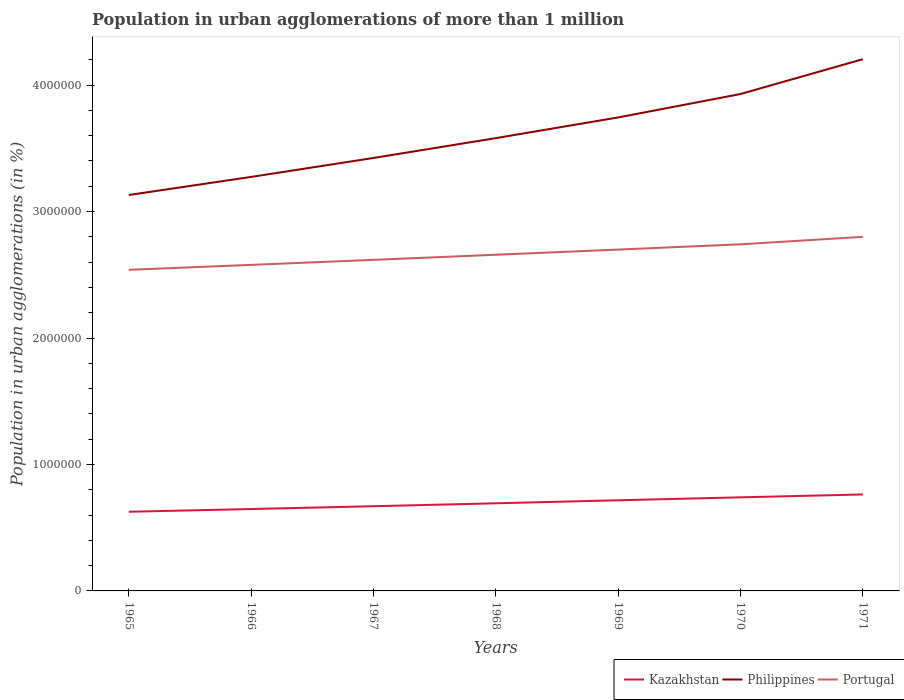How many different coloured lines are there?
Keep it short and to the point. 3. Does the line corresponding to Philippines intersect with the line corresponding to Kazakhstan?
Keep it short and to the point. No. Across all years, what is the maximum population in urban agglomerations in Portugal?
Offer a very short reply. 2.54e+06. In which year was the population in urban agglomerations in Portugal maximum?
Your response must be concise. 1965. What is the total population in urban agglomerations in Portugal in the graph?
Give a very brief answer. -1.42e+05. What is the difference between the highest and the second highest population in urban agglomerations in Portugal?
Your answer should be very brief. 2.61e+05. How many lines are there?
Offer a terse response. 3. How many years are there in the graph?
Give a very brief answer. 7. Are the values on the major ticks of Y-axis written in scientific E-notation?
Keep it short and to the point. No. How many legend labels are there?
Offer a terse response. 3. How are the legend labels stacked?
Your response must be concise. Horizontal. What is the title of the graph?
Ensure brevity in your answer.  Population in urban agglomerations of more than 1 million. Does "Mauritius" appear as one of the legend labels in the graph?
Your response must be concise. No. What is the label or title of the X-axis?
Keep it short and to the point. Years. What is the label or title of the Y-axis?
Ensure brevity in your answer.  Population in urban agglomerations (in %). What is the Population in urban agglomerations (in %) of Kazakhstan in 1965?
Ensure brevity in your answer.  6.26e+05. What is the Population in urban agglomerations (in %) in Philippines in 1965?
Offer a terse response. 3.13e+06. What is the Population in urban agglomerations (in %) of Portugal in 1965?
Your answer should be very brief. 2.54e+06. What is the Population in urban agglomerations (in %) of Kazakhstan in 1966?
Offer a very short reply. 6.48e+05. What is the Population in urban agglomerations (in %) of Philippines in 1966?
Provide a succinct answer. 3.27e+06. What is the Population in urban agglomerations (in %) in Portugal in 1966?
Offer a very short reply. 2.58e+06. What is the Population in urban agglomerations (in %) in Kazakhstan in 1967?
Your answer should be very brief. 6.70e+05. What is the Population in urban agglomerations (in %) in Philippines in 1967?
Ensure brevity in your answer.  3.42e+06. What is the Population in urban agglomerations (in %) of Portugal in 1967?
Keep it short and to the point. 2.62e+06. What is the Population in urban agglomerations (in %) in Kazakhstan in 1968?
Provide a short and direct response. 6.93e+05. What is the Population in urban agglomerations (in %) of Philippines in 1968?
Your answer should be very brief. 3.58e+06. What is the Population in urban agglomerations (in %) of Portugal in 1968?
Give a very brief answer. 2.66e+06. What is the Population in urban agglomerations (in %) in Kazakhstan in 1969?
Make the answer very short. 7.17e+05. What is the Population in urban agglomerations (in %) in Philippines in 1969?
Keep it short and to the point. 3.74e+06. What is the Population in urban agglomerations (in %) of Portugal in 1969?
Make the answer very short. 2.70e+06. What is the Population in urban agglomerations (in %) in Kazakhstan in 1970?
Ensure brevity in your answer.  7.40e+05. What is the Population in urban agglomerations (in %) of Philippines in 1970?
Ensure brevity in your answer.  3.93e+06. What is the Population in urban agglomerations (in %) of Portugal in 1970?
Keep it short and to the point. 2.74e+06. What is the Population in urban agglomerations (in %) of Kazakhstan in 1971?
Your answer should be very brief. 7.63e+05. What is the Population in urban agglomerations (in %) of Philippines in 1971?
Make the answer very short. 4.20e+06. What is the Population in urban agglomerations (in %) of Portugal in 1971?
Keep it short and to the point. 2.80e+06. Across all years, what is the maximum Population in urban agglomerations (in %) of Kazakhstan?
Your answer should be very brief. 7.63e+05. Across all years, what is the maximum Population in urban agglomerations (in %) in Philippines?
Provide a succinct answer. 4.20e+06. Across all years, what is the maximum Population in urban agglomerations (in %) of Portugal?
Keep it short and to the point. 2.80e+06. Across all years, what is the minimum Population in urban agglomerations (in %) of Kazakhstan?
Offer a terse response. 6.26e+05. Across all years, what is the minimum Population in urban agglomerations (in %) in Philippines?
Give a very brief answer. 3.13e+06. Across all years, what is the minimum Population in urban agglomerations (in %) in Portugal?
Your answer should be compact. 2.54e+06. What is the total Population in urban agglomerations (in %) in Kazakhstan in the graph?
Make the answer very short. 4.86e+06. What is the total Population in urban agglomerations (in %) of Philippines in the graph?
Offer a terse response. 2.53e+07. What is the total Population in urban agglomerations (in %) of Portugal in the graph?
Offer a terse response. 1.86e+07. What is the difference between the Population in urban agglomerations (in %) of Kazakhstan in 1965 and that in 1966?
Your answer should be compact. -2.15e+04. What is the difference between the Population in urban agglomerations (in %) of Philippines in 1965 and that in 1966?
Your response must be concise. -1.43e+05. What is the difference between the Population in urban agglomerations (in %) of Portugal in 1965 and that in 1966?
Your response must be concise. -3.90e+04. What is the difference between the Population in urban agglomerations (in %) in Kazakhstan in 1965 and that in 1967?
Give a very brief answer. -4.38e+04. What is the difference between the Population in urban agglomerations (in %) of Philippines in 1965 and that in 1967?
Offer a terse response. -2.93e+05. What is the difference between the Population in urban agglomerations (in %) of Portugal in 1965 and that in 1967?
Give a very brief answer. -7.87e+04. What is the difference between the Population in urban agglomerations (in %) of Kazakhstan in 1965 and that in 1968?
Your answer should be very brief. -6.69e+04. What is the difference between the Population in urban agglomerations (in %) of Philippines in 1965 and that in 1968?
Provide a succinct answer. -4.50e+05. What is the difference between the Population in urban agglomerations (in %) in Portugal in 1965 and that in 1968?
Provide a short and direct response. -1.19e+05. What is the difference between the Population in urban agglomerations (in %) of Kazakhstan in 1965 and that in 1969?
Your answer should be compact. -9.07e+04. What is the difference between the Population in urban agglomerations (in %) in Philippines in 1965 and that in 1969?
Give a very brief answer. -6.13e+05. What is the difference between the Population in urban agglomerations (in %) of Portugal in 1965 and that in 1969?
Your answer should be very brief. -1.60e+05. What is the difference between the Population in urban agglomerations (in %) of Kazakhstan in 1965 and that in 1970?
Your answer should be compact. -1.14e+05. What is the difference between the Population in urban agglomerations (in %) of Philippines in 1965 and that in 1970?
Your answer should be compact. -7.99e+05. What is the difference between the Population in urban agglomerations (in %) in Portugal in 1965 and that in 1970?
Ensure brevity in your answer.  -2.02e+05. What is the difference between the Population in urban agglomerations (in %) of Kazakhstan in 1965 and that in 1971?
Give a very brief answer. -1.37e+05. What is the difference between the Population in urban agglomerations (in %) in Philippines in 1965 and that in 1971?
Offer a terse response. -1.07e+06. What is the difference between the Population in urban agglomerations (in %) of Portugal in 1965 and that in 1971?
Provide a short and direct response. -2.61e+05. What is the difference between the Population in urban agglomerations (in %) of Kazakhstan in 1966 and that in 1967?
Provide a succinct answer. -2.23e+04. What is the difference between the Population in urban agglomerations (in %) in Philippines in 1966 and that in 1967?
Ensure brevity in your answer.  -1.50e+05. What is the difference between the Population in urban agglomerations (in %) of Portugal in 1966 and that in 1967?
Offer a terse response. -3.97e+04. What is the difference between the Population in urban agglomerations (in %) of Kazakhstan in 1966 and that in 1968?
Your answer should be compact. -4.54e+04. What is the difference between the Population in urban agglomerations (in %) of Philippines in 1966 and that in 1968?
Offer a very short reply. -3.07e+05. What is the difference between the Population in urban agglomerations (in %) in Portugal in 1966 and that in 1968?
Ensure brevity in your answer.  -8.00e+04. What is the difference between the Population in urban agglomerations (in %) of Kazakhstan in 1966 and that in 1969?
Make the answer very short. -6.92e+04. What is the difference between the Population in urban agglomerations (in %) of Philippines in 1966 and that in 1969?
Keep it short and to the point. -4.70e+05. What is the difference between the Population in urban agglomerations (in %) in Portugal in 1966 and that in 1969?
Your response must be concise. -1.21e+05. What is the difference between the Population in urban agglomerations (in %) of Kazakhstan in 1966 and that in 1970?
Your answer should be very brief. -9.25e+04. What is the difference between the Population in urban agglomerations (in %) in Philippines in 1966 and that in 1970?
Provide a succinct answer. -6.55e+05. What is the difference between the Population in urban agglomerations (in %) of Portugal in 1966 and that in 1970?
Your answer should be very brief. -1.63e+05. What is the difference between the Population in urban agglomerations (in %) of Kazakhstan in 1966 and that in 1971?
Make the answer very short. -1.15e+05. What is the difference between the Population in urban agglomerations (in %) in Philippines in 1966 and that in 1971?
Ensure brevity in your answer.  -9.31e+05. What is the difference between the Population in urban agglomerations (in %) of Portugal in 1966 and that in 1971?
Make the answer very short. -2.22e+05. What is the difference between the Population in urban agglomerations (in %) of Kazakhstan in 1967 and that in 1968?
Ensure brevity in your answer.  -2.31e+04. What is the difference between the Population in urban agglomerations (in %) of Philippines in 1967 and that in 1968?
Your answer should be compact. -1.57e+05. What is the difference between the Population in urban agglomerations (in %) of Portugal in 1967 and that in 1968?
Your response must be concise. -4.04e+04. What is the difference between the Population in urban agglomerations (in %) of Kazakhstan in 1967 and that in 1969?
Give a very brief answer. -4.69e+04. What is the difference between the Population in urban agglomerations (in %) of Philippines in 1967 and that in 1969?
Your response must be concise. -3.20e+05. What is the difference between the Population in urban agglomerations (in %) in Portugal in 1967 and that in 1969?
Your answer should be compact. -8.13e+04. What is the difference between the Population in urban agglomerations (in %) of Kazakhstan in 1967 and that in 1970?
Your response must be concise. -7.03e+04. What is the difference between the Population in urban agglomerations (in %) of Philippines in 1967 and that in 1970?
Offer a very short reply. -5.06e+05. What is the difference between the Population in urban agglomerations (in %) in Portugal in 1967 and that in 1970?
Give a very brief answer. -1.23e+05. What is the difference between the Population in urban agglomerations (in %) in Kazakhstan in 1967 and that in 1971?
Offer a terse response. -9.28e+04. What is the difference between the Population in urban agglomerations (in %) in Philippines in 1967 and that in 1971?
Provide a short and direct response. -7.81e+05. What is the difference between the Population in urban agglomerations (in %) in Portugal in 1967 and that in 1971?
Make the answer very short. -1.82e+05. What is the difference between the Population in urban agglomerations (in %) of Kazakhstan in 1968 and that in 1969?
Provide a succinct answer. -2.38e+04. What is the difference between the Population in urban agglomerations (in %) of Philippines in 1968 and that in 1969?
Your answer should be very brief. -1.64e+05. What is the difference between the Population in urban agglomerations (in %) of Portugal in 1968 and that in 1969?
Your response must be concise. -4.09e+04. What is the difference between the Population in urban agglomerations (in %) of Kazakhstan in 1968 and that in 1970?
Give a very brief answer. -4.72e+04. What is the difference between the Population in urban agglomerations (in %) in Philippines in 1968 and that in 1970?
Your answer should be very brief. -3.49e+05. What is the difference between the Population in urban agglomerations (in %) of Portugal in 1968 and that in 1970?
Give a very brief answer. -8.26e+04. What is the difference between the Population in urban agglomerations (in %) of Kazakhstan in 1968 and that in 1971?
Offer a terse response. -6.98e+04. What is the difference between the Population in urban agglomerations (in %) of Philippines in 1968 and that in 1971?
Offer a very short reply. -6.24e+05. What is the difference between the Population in urban agglomerations (in %) in Portugal in 1968 and that in 1971?
Provide a succinct answer. -1.42e+05. What is the difference between the Population in urban agglomerations (in %) in Kazakhstan in 1969 and that in 1970?
Provide a succinct answer. -2.34e+04. What is the difference between the Population in urban agglomerations (in %) in Philippines in 1969 and that in 1970?
Your response must be concise. -1.85e+05. What is the difference between the Population in urban agglomerations (in %) of Portugal in 1969 and that in 1970?
Ensure brevity in your answer.  -4.17e+04. What is the difference between the Population in urban agglomerations (in %) of Kazakhstan in 1969 and that in 1971?
Offer a very short reply. -4.59e+04. What is the difference between the Population in urban agglomerations (in %) of Philippines in 1969 and that in 1971?
Your answer should be compact. -4.61e+05. What is the difference between the Population in urban agglomerations (in %) of Portugal in 1969 and that in 1971?
Your answer should be very brief. -1.01e+05. What is the difference between the Population in urban agglomerations (in %) of Kazakhstan in 1970 and that in 1971?
Give a very brief answer. -2.26e+04. What is the difference between the Population in urban agglomerations (in %) in Philippines in 1970 and that in 1971?
Ensure brevity in your answer.  -2.75e+05. What is the difference between the Population in urban agglomerations (in %) of Portugal in 1970 and that in 1971?
Your response must be concise. -5.90e+04. What is the difference between the Population in urban agglomerations (in %) of Kazakhstan in 1965 and the Population in urban agglomerations (in %) of Philippines in 1966?
Your response must be concise. -2.65e+06. What is the difference between the Population in urban agglomerations (in %) in Kazakhstan in 1965 and the Population in urban agglomerations (in %) in Portugal in 1966?
Ensure brevity in your answer.  -1.95e+06. What is the difference between the Population in urban agglomerations (in %) of Philippines in 1965 and the Population in urban agglomerations (in %) of Portugal in 1966?
Provide a short and direct response. 5.52e+05. What is the difference between the Population in urban agglomerations (in %) in Kazakhstan in 1965 and the Population in urban agglomerations (in %) in Philippines in 1967?
Give a very brief answer. -2.80e+06. What is the difference between the Population in urban agglomerations (in %) of Kazakhstan in 1965 and the Population in urban agglomerations (in %) of Portugal in 1967?
Give a very brief answer. -1.99e+06. What is the difference between the Population in urban agglomerations (in %) in Philippines in 1965 and the Population in urban agglomerations (in %) in Portugal in 1967?
Your answer should be compact. 5.13e+05. What is the difference between the Population in urban agglomerations (in %) in Kazakhstan in 1965 and the Population in urban agglomerations (in %) in Philippines in 1968?
Your answer should be very brief. -2.95e+06. What is the difference between the Population in urban agglomerations (in %) in Kazakhstan in 1965 and the Population in urban agglomerations (in %) in Portugal in 1968?
Your response must be concise. -2.03e+06. What is the difference between the Population in urban agglomerations (in %) of Philippines in 1965 and the Population in urban agglomerations (in %) of Portugal in 1968?
Your answer should be very brief. 4.72e+05. What is the difference between the Population in urban agglomerations (in %) of Kazakhstan in 1965 and the Population in urban agglomerations (in %) of Philippines in 1969?
Give a very brief answer. -3.12e+06. What is the difference between the Population in urban agglomerations (in %) in Kazakhstan in 1965 and the Population in urban agglomerations (in %) in Portugal in 1969?
Offer a very short reply. -2.07e+06. What is the difference between the Population in urban agglomerations (in %) in Philippines in 1965 and the Population in urban agglomerations (in %) in Portugal in 1969?
Give a very brief answer. 4.32e+05. What is the difference between the Population in urban agglomerations (in %) in Kazakhstan in 1965 and the Population in urban agglomerations (in %) in Philippines in 1970?
Ensure brevity in your answer.  -3.30e+06. What is the difference between the Population in urban agglomerations (in %) of Kazakhstan in 1965 and the Population in urban agglomerations (in %) of Portugal in 1970?
Provide a succinct answer. -2.11e+06. What is the difference between the Population in urban agglomerations (in %) in Philippines in 1965 and the Population in urban agglomerations (in %) in Portugal in 1970?
Offer a terse response. 3.90e+05. What is the difference between the Population in urban agglomerations (in %) in Kazakhstan in 1965 and the Population in urban agglomerations (in %) in Philippines in 1971?
Keep it short and to the point. -3.58e+06. What is the difference between the Population in urban agglomerations (in %) in Kazakhstan in 1965 and the Population in urban agglomerations (in %) in Portugal in 1971?
Your answer should be very brief. -2.17e+06. What is the difference between the Population in urban agglomerations (in %) in Philippines in 1965 and the Population in urban agglomerations (in %) in Portugal in 1971?
Ensure brevity in your answer.  3.31e+05. What is the difference between the Population in urban agglomerations (in %) of Kazakhstan in 1966 and the Population in urban agglomerations (in %) of Philippines in 1967?
Your response must be concise. -2.78e+06. What is the difference between the Population in urban agglomerations (in %) of Kazakhstan in 1966 and the Population in urban agglomerations (in %) of Portugal in 1967?
Make the answer very short. -1.97e+06. What is the difference between the Population in urban agglomerations (in %) in Philippines in 1966 and the Population in urban agglomerations (in %) in Portugal in 1967?
Your answer should be compact. 6.56e+05. What is the difference between the Population in urban agglomerations (in %) of Kazakhstan in 1966 and the Population in urban agglomerations (in %) of Philippines in 1968?
Make the answer very short. -2.93e+06. What is the difference between the Population in urban agglomerations (in %) in Kazakhstan in 1966 and the Population in urban agglomerations (in %) in Portugal in 1968?
Provide a short and direct response. -2.01e+06. What is the difference between the Population in urban agglomerations (in %) of Philippines in 1966 and the Population in urban agglomerations (in %) of Portugal in 1968?
Make the answer very short. 6.16e+05. What is the difference between the Population in urban agglomerations (in %) of Kazakhstan in 1966 and the Population in urban agglomerations (in %) of Philippines in 1969?
Your response must be concise. -3.10e+06. What is the difference between the Population in urban agglomerations (in %) of Kazakhstan in 1966 and the Population in urban agglomerations (in %) of Portugal in 1969?
Offer a terse response. -2.05e+06. What is the difference between the Population in urban agglomerations (in %) in Philippines in 1966 and the Population in urban agglomerations (in %) in Portugal in 1969?
Offer a terse response. 5.75e+05. What is the difference between the Population in urban agglomerations (in %) in Kazakhstan in 1966 and the Population in urban agglomerations (in %) in Philippines in 1970?
Ensure brevity in your answer.  -3.28e+06. What is the difference between the Population in urban agglomerations (in %) in Kazakhstan in 1966 and the Population in urban agglomerations (in %) in Portugal in 1970?
Your response must be concise. -2.09e+06. What is the difference between the Population in urban agglomerations (in %) in Philippines in 1966 and the Population in urban agglomerations (in %) in Portugal in 1970?
Provide a short and direct response. 5.33e+05. What is the difference between the Population in urban agglomerations (in %) of Kazakhstan in 1966 and the Population in urban agglomerations (in %) of Philippines in 1971?
Provide a short and direct response. -3.56e+06. What is the difference between the Population in urban agglomerations (in %) of Kazakhstan in 1966 and the Population in urban agglomerations (in %) of Portugal in 1971?
Your response must be concise. -2.15e+06. What is the difference between the Population in urban agglomerations (in %) in Philippines in 1966 and the Population in urban agglomerations (in %) in Portugal in 1971?
Your answer should be very brief. 4.74e+05. What is the difference between the Population in urban agglomerations (in %) of Kazakhstan in 1967 and the Population in urban agglomerations (in %) of Philippines in 1968?
Your response must be concise. -2.91e+06. What is the difference between the Population in urban agglomerations (in %) of Kazakhstan in 1967 and the Population in urban agglomerations (in %) of Portugal in 1968?
Keep it short and to the point. -1.99e+06. What is the difference between the Population in urban agglomerations (in %) of Philippines in 1967 and the Population in urban agglomerations (in %) of Portugal in 1968?
Ensure brevity in your answer.  7.65e+05. What is the difference between the Population in urban agglomerations (in %) in Kazakhstan in 1967 and the Population in urban agglomerations (in %) in Philippines in 1969?
Give a very brief answer. -3.07e+06. What is the difference between the Population in urban agglomerations (in %) in Kazakhstan in 1967 and the Population in urban agglomerations (in %) in Portugal in 1969?
Your response must be concise. -2.03e+06. What is the difference between the Population in urban agglomerations (in %) of Philippines in 1967 and the Population in urban agglomerations (in %) of Portugal in 1969?
Your answer should be compact. 7.24e+05. What is the difference between the Population in urban agglomerations (in %) of Kazakhstan in 1967 and the Population in urban agglomerations (in %) of Philippines in 1970?
Your answer should be compact. -3.26e+06. What is the difference between the Population in urban agglomerations (in %) of Kazakhstan in 1967 and the Population in urban agglomerations (in %) of Portugal in 1970?
Your response must be concise. -2.07e+06. What is the difference between the Population in urban agglomerations (in %) in Philippines in 1967 and the Population in urban agglomerations (in %) in Portugal in 1970?
Your response must be concise. 6.83e+05. What is the difference between the Population in urban agglomerations (in %) of Kazakhstan in 1967 and the Population in urban agglomerations (in %) of Philippines in 1971?
Give a very brief answer. -3.53e+06. What is the difference between the Population in urban agglomerations (in %) in Kazakhstan in 1967 and the Population in urban agglomerations (in %) in Portugal in 1971?
Provide a short and direct response. -2.13e+06. What is the difference between the Population in urban agglomerations (in %) of Philippines in 1967 and the Population in urban agglomerations (in %) of Portugal in 1971?
Make the answer very short. 6.24e+05. What is the difference between the Population in urban agglomerations (in %) of Kazakhstan in 1968 and the Population in urban agglomerations (in %) of Philippines in 1969?
Make the answer very short. -3.05e+06. What is the difference between the Population in urban agglomerations (in %) of Kazakhstan in 1968 and the Population in urban agglomerations (in %) of Portugal in 1969?
Your answer should be very brief. -2.01e+06. What is the difference between the Population in urban agglomerations (in %) of Philippines in 1968 and the Population in urban agglomerations (in %) of Portugal in 1969?
Give a very brief answer. 8.81e+05. What is the difference between the Population in urban agglomerations (in %) in Kazakhstan in 1968 and the Population in urban agglomerations (in %) in Philippines in 1970?
Your answer should be compact. -3.24e+06. What is the difference between the Population in urban agglomerations (in %) in Kazakhstan in 1968 and the Population in urban agglomerations (in %) in Portugal in 1970?
Ensure brevity in your answer.  -2.05e+06. What is the difference between the Population in urban agglomerations (in %) of Philippines in 1968 and the Population in urban agglomerations (in %) of Portugal in 1970?
Ensure brevity in your answer.  8.40e+05. What is the difference between the Population in urban agglomerations (in %) of Kazakhstan in 1968 and the Population in urban agglomerations (in %) of Philippines in 1971?
Ensure brevity in your answer.  -3.51e+06. What is the difference between the Population in urban agglomerations (in %) of Kazakhstan in 1968 and the Population in urban agglomerations (in %) of Portugal in 1971?
Keep it short and to the point. -2.11e+06. What is the difference between the Population in urban agglomerations (in %) of Philippines in 1968 and the Population in urban agglomerations (in %) of Portugal in 1971?
Provide a short and direct response. 7.81e+05. What is the difference between the Population in urban agglomerations (in %) of Kazakhstan in 1969 and the Population in urban agglomerations (in %) of Philippines in 1970?
Make the answer very short. -3.21e+06. What is the difference between the Population in urban agglomerations (in %) in Kazakhstan in 1969 and the Population in urban agglomerations (in %) in Portugal in 1970?
Your response must be concise. -2.02e+06. What is the difference between the Population in urban agglomerations (in %) of Philippines in 1969 and the Population in urban agglomerations (in %) of Portugal in 1970?
Make the answer very short. 1.00e+06. What is the difference between the Population in urban agglomerations (in %) of Kazakhstan in 1969 and the Population in urban agglomerations (in %) of Philippines in 1971?
Make the answer very short. -3.49e+06. What is the difference between the Population in urban agglomerations (in %) of Kazakhstan in 1969 and the Population in urban agglomerations (in %) of Portugal in 1971?
Ensure brevity in your answer.  -2.08e+06. What is the difference between the Population in urban agglomerations (in %) in Philippines in 1969 and the Population in urban agglomerations (in %) in Portugal in 1971?
Give a very brief answer. 9.44e+05. What is the difference between the Population in urban agglomerations (in %) in Kazakhstan in 1970 and the Population in urban agglomerations (in %) in Philippines in 1971?
Provide a short and direct response. -3.46e+06. What is the difference between the Population in urban agglomerations (in %) of Kazakhstan in 1970 and the Population in urban agglomerations (in %) of Portugal in 1971?
Your response must be concise. -2.06e+06. What is the difference between the Population in urban agglomerations (in %) of Philippines in 1970 and the Population in urban agglomerations (in %) of Portugal in 1971?
Ensure brevity in your answer.  1.13e+06. What is the average Population in urban agglomerations (in %) of Kazakhstan per year?
Offer a terse response. 6.94e+05. What is the average Population in urban agglomerations (in %) of Philippines per year?
Give a very brief answer. 3.61e+06. What is the average Population in urban agglomerations (in %) of Portugal per year?
Offer a terse response. 2.66e+06. In the year 1965, what is the difference between the Population in urban agglomerations (in %) in Kazakhstan and Population in urban agglomerations (in %) in Philippines?
Provide a succinct answer. -2.50e+06. In the year 1965, what is the difference between the Population in urban agglomerations (in %) of Kazakhstan and Population in urban agglomerations (in %) of Portugal?
Give a very brief answer. -1.91e+06. In the year 1965, what is the difference between the Population in urban agglomerations (in %) of Philippines and Population in urban agglomerations (in %) of Portugal?
Your answer should be very brief. 5.92e+05. In the year 1966, what is the difference between the Population in urban agglomerations (in %) of Kazakhstan and Population in urban agglomerations (in %) of Philippines?
Your answer should be compact. -2.63e+06. In the year 1966, what is the difference between the Population in urban agglomerations (in %) of Kazakhstan and Population in urban agglomerations (in %) of Portugal?
Keep it short and to the point. -1.93e+06. In the year 1966, what is the difference between the Population in urban agglomerations (in %) in Philippines and Population in urban agglomerations (in %) in Portugal?
Your response must be concise. 6.96e+05. In the year 1967, what is the difference between the Population in urban agglomerations (in %) in Kazakhstan and Population in urban agglomerations (in %) in Philippines?
Ensure brevity in your answer.  -2.75e+06. In the year 1967, what is the difference between the Population in urban agglomerations (in %) in Kazakhstan and Population in urban agglomerations (in %) in Portugal?
Keep it short and to the point. -1.95e+06. In the year 1967, what is the difference between the Population in urban agglomerations (in %) of Philippines and Population in urban agglomerations (in %) of Portugal?
Ensure brevity in your answer.  8.06e+05. In the year 1968, what is the difference between the Population in urban agglomerations (in %) of Kazakhstan and Population in urban agglomerations (in %) of Philippines?
Your response must be concise. -2.89e+06. In the year 1968, what is the difference between the Population in urban agglomerations (in %) in Kazakhstan and Population in urban agglomerations (in %) in Portugal?
Keep it short and to the point. -1.97e+06. In the year 1968, what is the difference between the Population in urban agglomerations (in %) of Philippines and Population in urban agglomerations (in %) of Portugal?
Ensure brevity in your answer.  9.22e+05. In the year 1969, what is the difference between the Population in urban agglomerations (in %) of Kazakhstan and Population in urban agglomerations (in %) of Philippines?
Your answer should be compact. -3.03e+06. In the year 1969, what is the difference between the Population in urban agglomerations (in %) in Kazakhstan and Population in urban agglomerations (in %) in Portugal?
Keep it short and to the point. -1.98e+06. In the year 1969, what is the difference between the Population in urban agglomerations (in %) in Philippines and Population in urban agglomerations (in %) in Portugal?
Ensure brevity in your answer.  1.04e+06. In the year 1970, what is the difference between the Population in urban agglomerations (in %) in Kazakhstan and Population in urban agglomerations (in %) in Philippines?
Keep it short and to the point. -3.19e+06. In the year 1970, what is the difference between the Population in urban agglomerations (in %) of Kazakhstan and Population in urban agglomerations (in %) of Portugal?
Your response must be concise. -2.00e+06. In the year 1970, what is the difference between the Population in urban agglomerations (in %) of Philippines and Population in urban agglomerations (in %) of Portugal?
Your answer should be very brief. 1.19e+06. In the year 1971, what is the difference between the Population in urban agglomerations (in %) in Kazakhstan and Population in urban agglomerations (in %) in Philippines?
Give a very brief answer. -3.44e+06. In the year 1971, what is the difference between the Population in urban agglomerations (in %) of Kazakhstan and Population in urban agglomerations (in %) of Portugal?
Keep it short and to the point. -2.04e+06. In the year 1971, what is the difference between the Population in urban agglomerations (in %) of Philippines and Population in urban agglomerations (in %) of Portugal?
Give a very brief answer. 1.40e+06. What is the ratio of the Population in urban agglomerations (in %) of Kazakhstan in 1965 to that in 1966?
Provide a succinct answer. 0.97. What is the ratio of the Population in urban agglomerations (in %) in Philippines in 1965 to that in 1966?
Keep it short and to the point. 0.96. What is the ratio of the Population in urban agglomerations (in %) in Portugal in 1965 to that in 1966?
Keep it short and to the point. 0.98. What is the ratio of the Population in urban agglomerations (in %) of Kazakhstan in 1965 to that in 1967?
Your answer should be very brief. 0.93. What is the ratio of the Population in urban agglomerations (in %) of Philippines in 1965 to that in 1967?
Give a very brief answer. 0.91. What is the ratio of the Population in urban agglomerations (in %) in Portugal in 1965 to that in 1967?
Your answer should be compact. 0.97. What is the ratio of the Population in urban agglomerations (in %) of Kazakhstan in 1965 to that in 1968?
Offer a very short reply. 0.9. What is the ratio of the Population in urban agglomerations (in %) of Philippines in 1965 to that in 1968?
Offer a very short reply. 0.87. What is the ratio of the Population in urban agglomerations (in %) of Portugal in 1965 to that in 1968?
Offer a terse response. 0.96. What is the ratio of the Population in urban agglomerations (in %) of Kazakhstan in 1965 to that in 1969?
Ensure brevity in your answer.  0.87. What is the ratio of the Population in urban agglomerations (in %) in Philippines in 1965 to that in 1969?
Give a very brief answer. 0.84. What is the ratio of the Population in urban agglomerations (in %) of Portugal in 1965 to that in 1969?
Ensure brevity in your answer.  0.94. What is the ratio of the Population in urban agglomerations (in %) of Kazakhstan in 1965 to that in 1970?
Ensure brevity in your answer.  0.85. What is the ratio of the Population in urban agglomerations (in %) of Philippines in 1965 to that in 1970?
Your answer should be compact. 0.8. What is the ratio of the Population in urban agglomerations (in %) of Portugal in 1965 to that in 1970?
Give a very brief answer. 0.93. What is the ratio of the Population in urban agglomerations (in %) of Kazakhstan in 1965 to that in 1971?
Your answer should be very brief. 0.82. What is the ratio of the Population in urban agglomerations (in %) in Philippines in 1965 to that in 1971?
Make the answer very short. 0.74. What is the ratio of the Population in urban agglomerations (in %) in Portugal in 1965 to that in 1971?
Make the answer very short. 0.91. What is the ratio of the Population in urban agglomerations (in %) of Kazakhstan in 1966 to that in 1967?
Offer a very short reply. 0.97. What is the ratio of the Population in urban agglomerations (in %) of Philippines in 1966 to that in 1967?
Give a very brief answer. 0.96. What is the ratio of the Population in urban agglomerations (in %) in Kazakhstan in 1966 to that in 1968?
Your answer should be very brief. 0.93. What is the ratio of the Population in urban agglomerations (in %) in Philippines in 1966 to that in 1968?
Give a very brief answer. 0.91. What is the ratio of the Population in urban agglomerations (in %) of Portugal in 1966 to that in 1968?
Give a very brief answer. 0.97. What is the ratio of the Population in urban agglomerations (in %) of Kazakhstan in 1966 to that in 1969?
Provide a short and direct response. 0.9. What is the ratio of the Population in urban agglomerations (in %) of Philippines in 1966 to that in 1969?
Ensure brevity in your answer.  0.87. What is the ratio of the Population in urban agglomerations (in %) in Portugal in 1966 to that in 1969?
Your response must be concise. 0.96. What is the ratio of the Population in urban agglomerations (in %) in Philippines in 1966 to that in 1970?
Provide a succinct answer. 0.83. What is the ratio of the Population in urban agglomerations (in %) of Portugal in 1966 to that in 1970?
Keep it short and to the point. 0.94. What is the ratio of the Population in urban agglomerations (in %) of Kazakhstan in 1966 to that in 1971?
Keep it short and to the point. 0.85. What is the ratio of the Population in urban agglomerations (in %) of Philippines in 1966 to that in 1971?
Give a very brief answer. 0.78. What is the ratio of the Population in urban agglomerations (in %) in Portugal in 1966 to that in 1971?
Your answer should be very brief. 0.92. What is the ratio of the Population in urban agglomerations (in %) of Kazakhstan in 1967 to that in 1968?
Offer a very short reply. 0.97. What is the ratio of the Population in urban agglomerations (in %) in Philippines in 1967 to that in 1968?
Make the answer very short. 0.96. What is the ratio of the Population in urban agglomerations (in %) of Portugal in 1967 to that in 1968?
Make the answer very short. 0.98. What is the ratio of the Population in urban agglomerations (in %) in Kazakhstan in 1967 to that in 1969?
Keep it short and to the point. 0.93. What is the ratio of the Population in urban agglomerations (in %) in Philippines in 1967 to that in 1969?
Your answer should be very brief. 0.91. What is the ratio of the Population in urban agglomerations (in %) of Portugal in 1967 to that in 1969?
Keep it short and to the point. 0.97. What is the ratio of the Population in urban agglomerations (in %) in Kazakhstan in 1967 to that in 1970?
Make the answer very short. 0.91. What is the ratio of the Population in urban agglomerations (in %) of Philippines in 1967 to that in 1970?
Your answer should be very brief. 0.87. What is the ratio of the Population in urban agglomerations (in %) in Portugal in 1967 to that in 1970?
Your answer should be very brief. 0.96. What is the ratio of the Population in urban agglomerations (in %) of Kazakhstan in 1967 to that in 1971?
Provide a short and direct response. 0.88. What is the ratio of the Population in urban agglomerations (in %) of Philippines in 1967 to that in 1971?
Ensure brevity in your answer.  0.81. What is the ratio of the Population in urban agglomerations (in %) of Portugal in 1967 to that in 1971?
Provide a succinct answer. 0.94. What is the ratio of the Population in urban agglomerations (in %) in Kazakhstan in 1968 to that in 1969?
Give a very brief answer. 0.97. What is the ratio of the Population in urban agglomerations (in %) of Philippines in 1968 to that in 1969?
Provide a succinct answer. 0.96. What is the ratio of the Population in urban agglomerations (in %) in Kazakhstan in 1968 to that in 1970?
Provide a short and direct response. 0.94. What is the ratio of the Population in urban agglomerations (in %) of Philippines in 1968 to that in 1970?
Ensure brevity in your answer.  0.91. What is the ratio of the Population in urban agglomerations (in %) in Portugal in 1968 to that in 1970?
Keep it short and to the point. 0.97. What is the ratio of the Population in urban agglomerations (in %) in Kazakhstan in 1968 to that in 1971?
Provide a short and direct response. 0.91. What is the ratio of the Population in urban agglomerations (in %) in Philippines in 1968 to that in 1971?
Provide a succinct answer. 0.85. What is the ratio of the Population in urban agglomerations (in %) of Portugal in 1968 to that in 1971?
Your answer should be compact. 0.95. What is the ratio of the Population in urban agglomerations (in %) in Kazakhstan in 1969 to that in 1970?
Give a very brief answer. 0.97. What is the ratio of the Population in urban agglomerations (in %) of Philippines in 1969 to that in 1970?
Offer a terse response. 0.95. What is the ratio of the Population in urban agglomerations (in %) of Kazakhstan in 1969 to that in 1971?
Offer a terse response. 0.94. What is the ratio of the Population in urban agglomerations (in %) in Philippines in 1969 to that in 1971?
Your response must be concise. 0.89. What is the ratio of the Population in urban agglomerations (in %) of Portugal in 1969 to that in 1971?
Your answer should be compact. 0.96. What is the ratio of the Population in urban agglomerations (in %) of Kazakhstan in 1970 to that in 1971?
Make the answer very short. 0.97. What is the ratio of the Population in urban agglomerations (in %) in Philippines in 1970 to that in 1971?
Give a very brief answer. 0.93. What is the ratio of the Population in urban agglomerations (in %) of Portugal in 1970 to that in 1971?
Offer a terse response. 0.98. What is the difference between the highest and the second highest Population in urban agglomerations (in %) in Kazakhstan?
Your answer should be very brief. 2.26e+04. What is the difference between the highest and the second highest Population in urban agglomerations (in %) in Philippines?
Offer a terse response. 2.75e+05. What is the difference between the highest and the second highest Population in urban agglomerations (in %) of Portugal?
Provide a short and direct response. 5.90e+04. What is the difference between the highest and the lowest Population in urban agglomerations (in %) in Kazakhstan?
Give a very brief answer. 1.37e+05. What is the difference between the highest and the lowest Population in urban agglomerations (in %) of Philippines?
Give a very brief answer. 1.07e+06. What is the difference between the highest and the lowest Population in urban agglomerations (in %) of Portugal?
Offer a very short reply. 2.61e+05. 